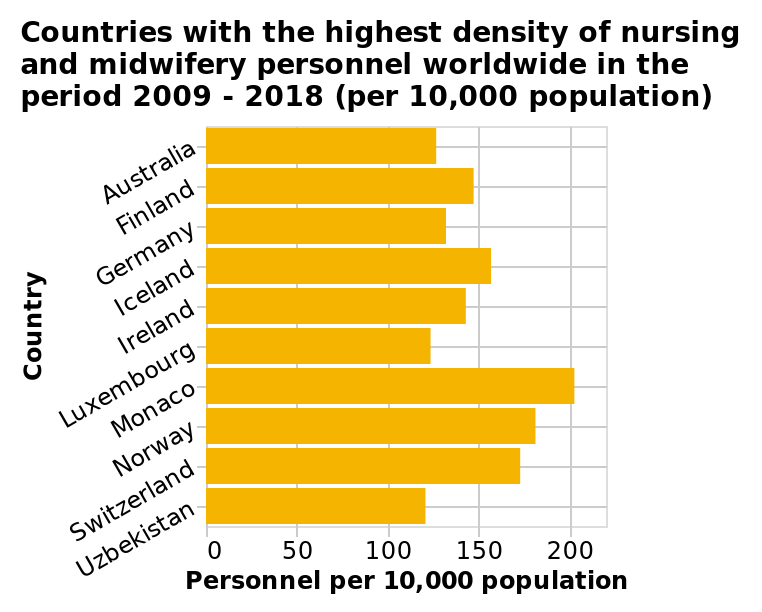<image>
What is the title of the bar diagram?  The title of the bar diagram is "Countries with the highest density of nursing and midwifery personnel worldwide in the period 2009 - 2018 (per 10,000 population)." What is the timeframe for the data represented in the bar diagram?  The data represented in the bar diagram is for the period 2009 - 2018. Which two countries had a similar score in terms of personal per every 10,000 population from 2009-2018?  Ireland and Finland had a similar score in terms of personal per every 10,000 population from 2009-2018. 